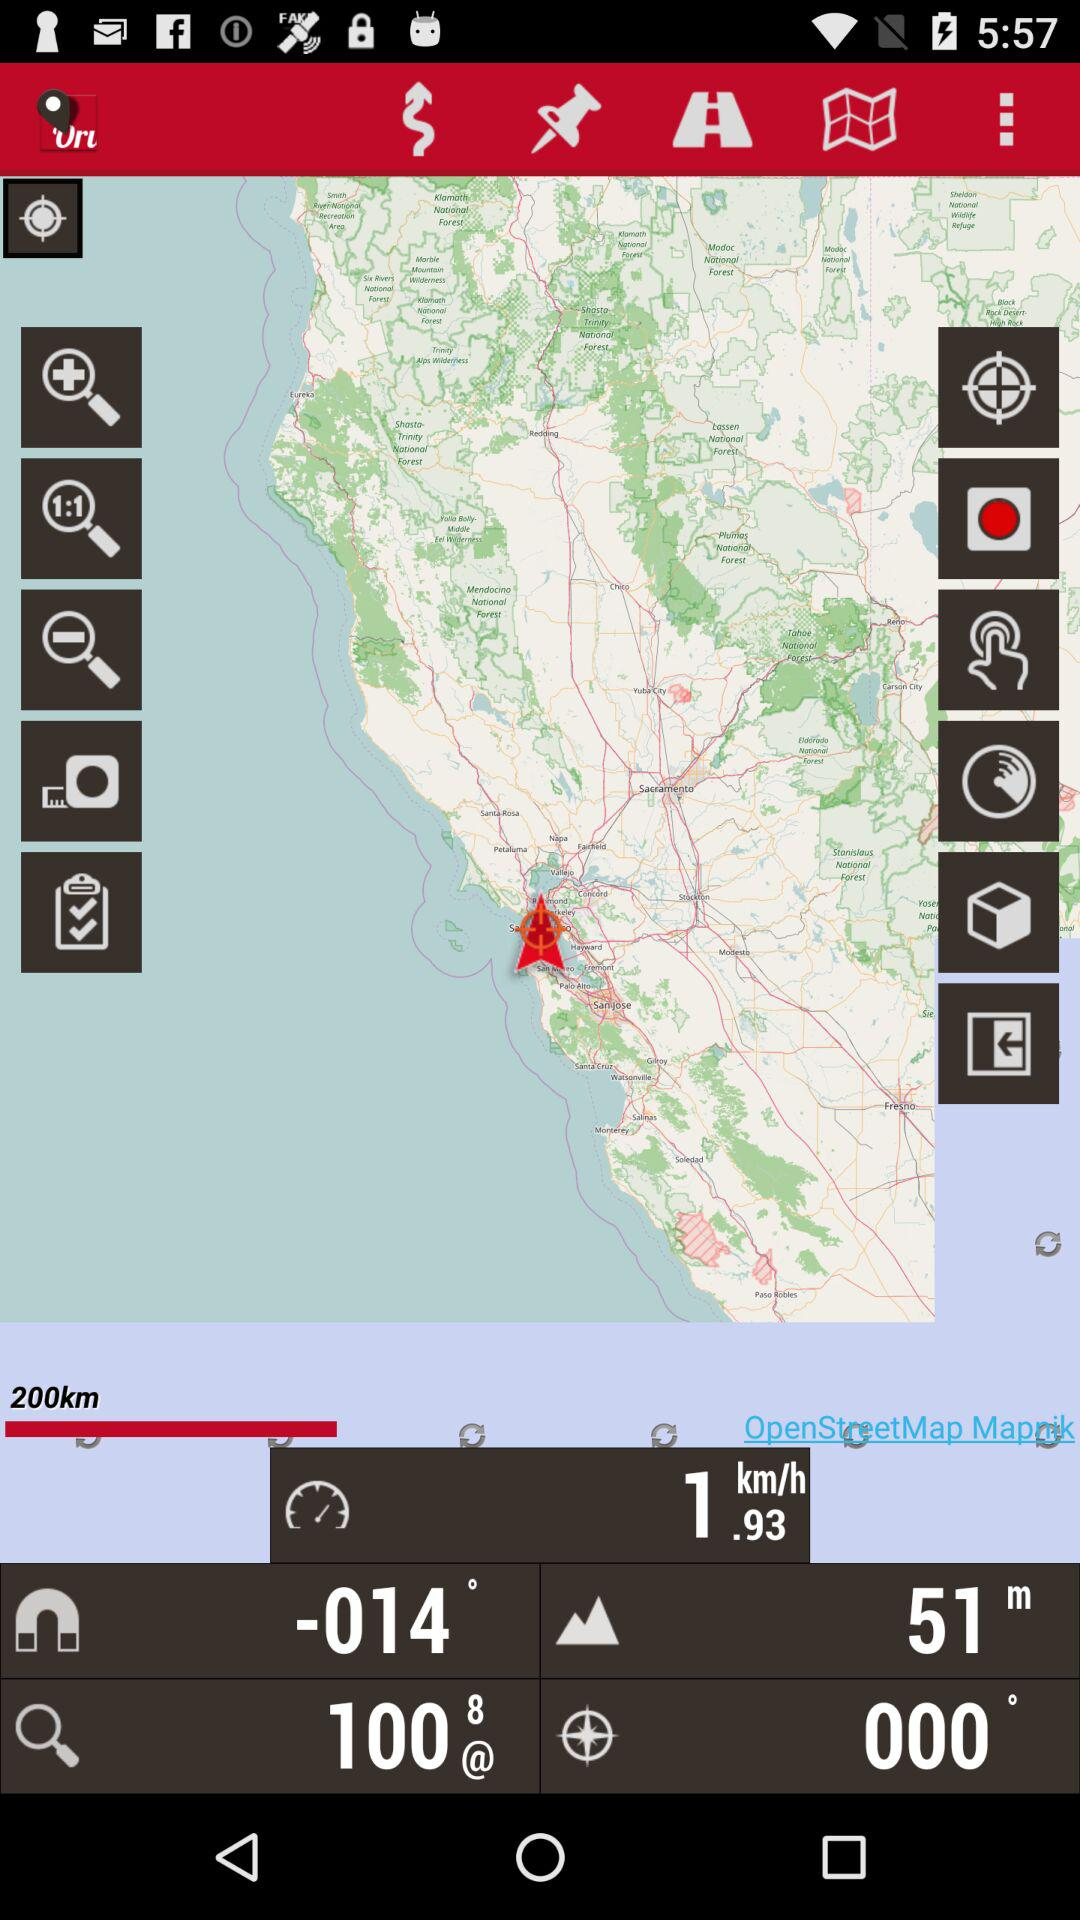What is the elevation? The elevation at the marked location in the San Francisco Bay Area, as shown on your map view, is 51 meters above sea level. This elevation is typical for coastal areas nearby major water bodies, contributing to the region's climate and environmental characteristics. 